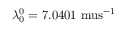<formula> <loc_0><loc_0><loc_500><loc_500>\lambda _ { 0 } ^ { 0 } = 7 . 0 4 0 1 \ m u s ^ { - 1 }</formula> 